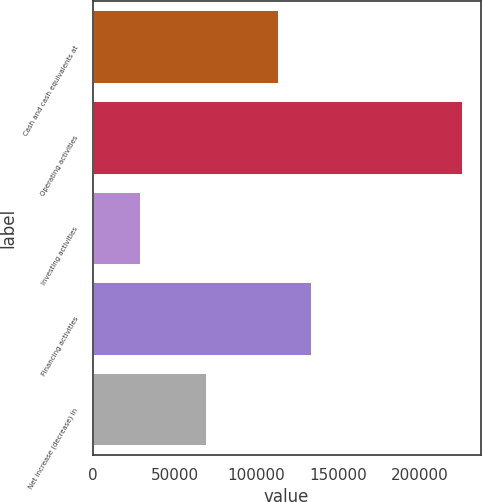Convert chart to OTSL. <chart><loc_0><loc_0><loc_500><loc_500><bar_chart><fcel>Cash and cash equivalents at<fcel>Operating activities<fcel>Investing activities<fcel>Financing activities<fcel>Net increase (decrease) in<nl><fcel>113159<fcel>225639<fcel>28873<fcel>133186<fcel>69255.6<nl></chart> 